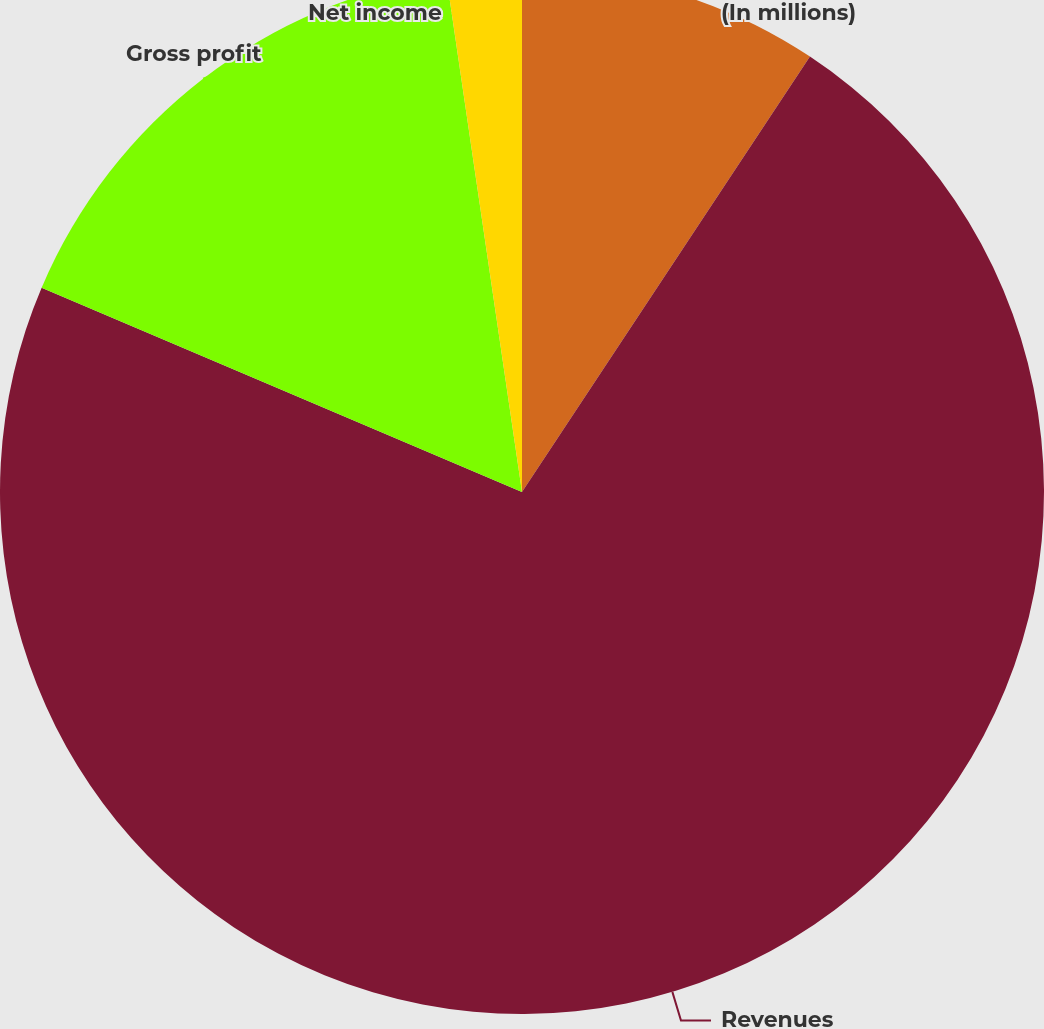Convert chart to OTSL. <chart><loc_0><loc_0><loc_500><loc_500><pie_chart><fcel>(In millions)<fcel>Revenues<fcel>Gross profit<fcel>Net income<nl><fcel>9.3%<fcel>72.1%<fcel>16.28%<fcel>2.32%<nl></chart> 